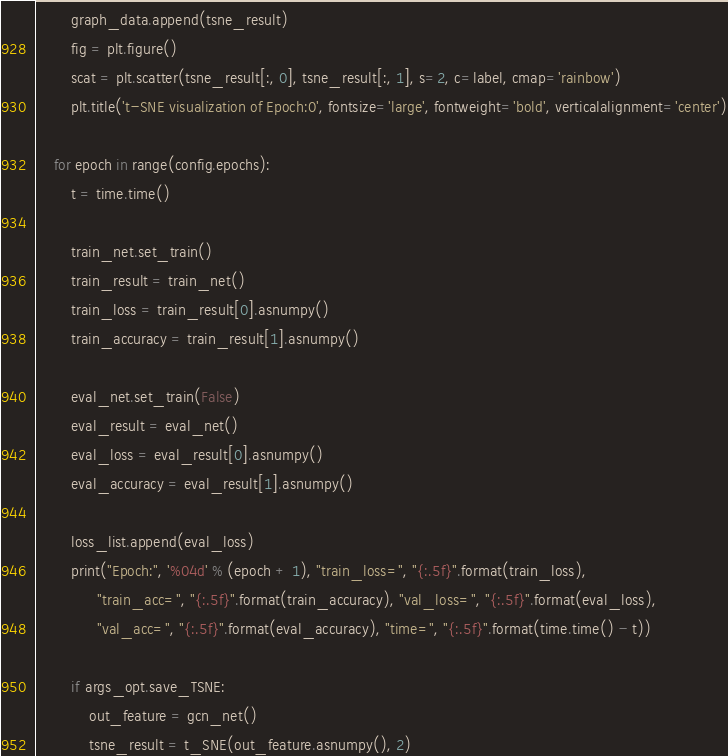<code> <loc_0><loc_0><loc_500><loc_500><_Python_>        graph_data.append(tsne_result)
        fig = plt.figure()
        scat = plt.scatter(tsne_result[:, 0], tsne_result[:, 1], s=2, c=label, cmap='rainbow')
        plt.title('t-SNE visualization of Epoch:0', fontsize='large', fontweight='bold', verticalalignment='center')

    for epoch in range(config.epochs):
        t = time.time()

        train_net.set_train()
        train_result = train_net()
        train_loss = train_result[0].asnumpy()
        train_accuracy = train_result[1].asnumpy()

        eval_net.set_train(False)
        eval_result = eval_net()
        eval_loss = eval_result[0].asnumpy()
        eval_accuracy = eval_result[1].asnumpy()

        loss_list.append(eval_loss)
        print("Epoch:", '%04d' % (epoch + 1), "train_loss=", "{:.5f}".format(train_loss),
              "train_acc=", "{:.5f}".format(train_accuracy), "val_loss=", "{:.5f}".format(eval_loss),
              "val_acc=", "{:.5f}".format(eval_accuracy), "time=", "{:.5f}".format(time.time() - t))

        if args_opt.save_TSNE:
            out_feature = gcn_net()
            tsne_result = t_SNE(out_feature.asnumpy(), 2)</code> 